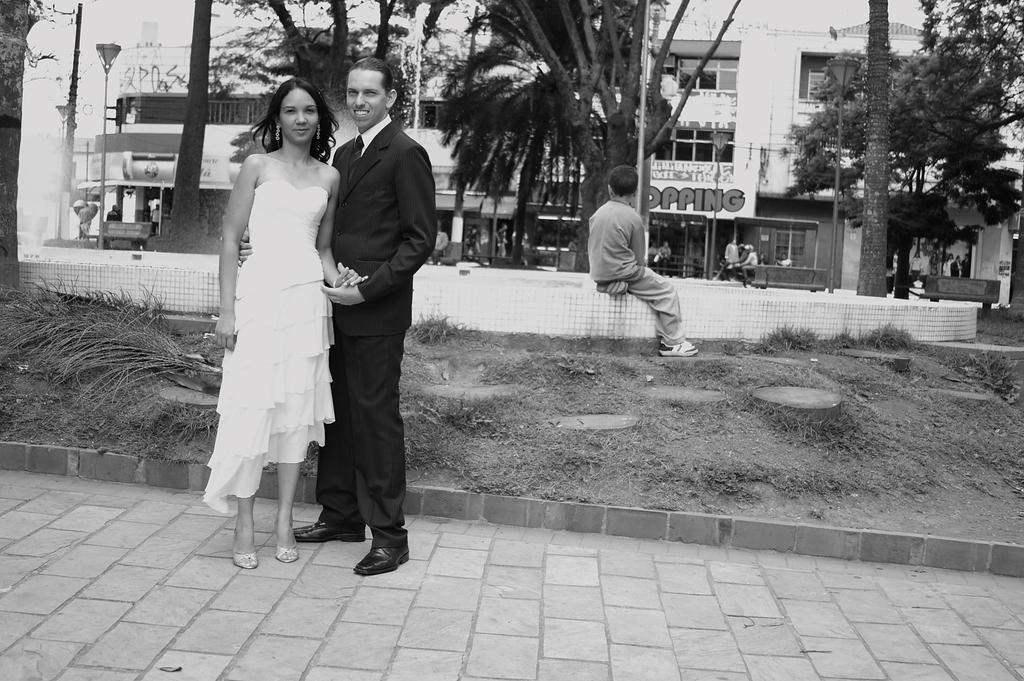Who is present in the image? There is a couple in the image. What is the couple doing in the image? The couple is smiling in the image. What can be seen in the background of the image? There is a child sitting on a wall, trees, and buildings in the background of the image. What type of humor can be seen in the image? There is no specific humor depicted in the image; it simply shows a smiling couple. What is the source of the crack in the image? There is no crack present in the image. 